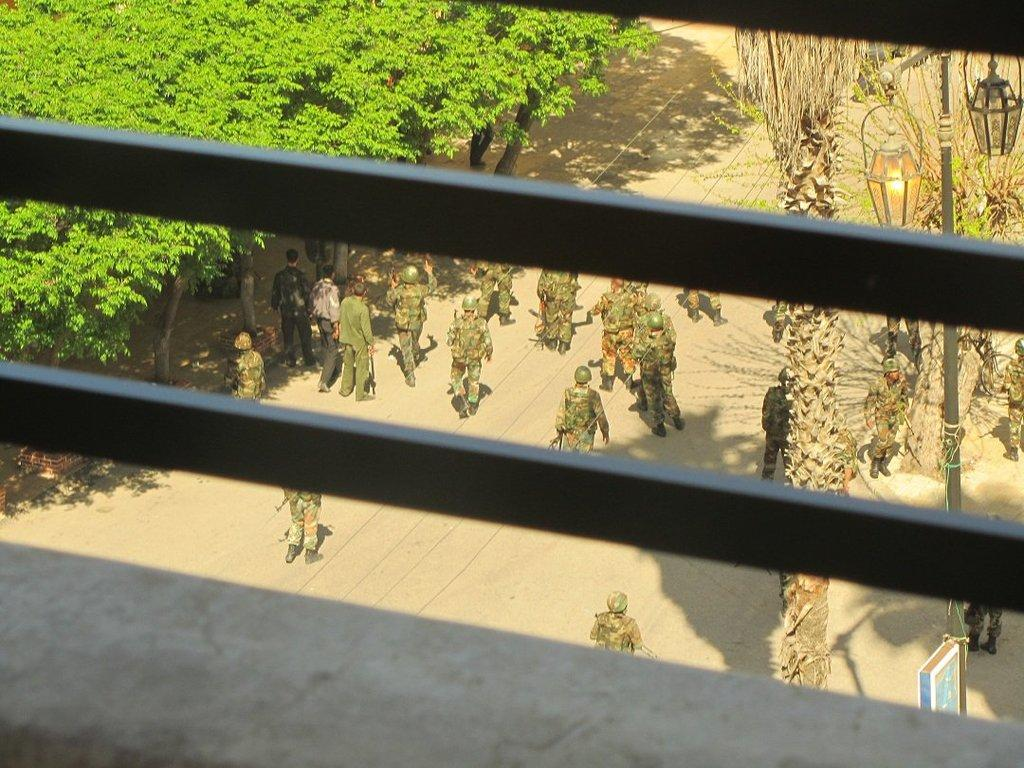What is the main feature in the middle of the picture? There is a black color railing in the middle of the picture. What can be seen in the background of the image? There are soldiers on the road in the background. What type of vegetation is on the left side of the image? There are trees on the left side of the image. Where is the school located in the image? There is no school present in the image. What type of rifle is being used by the soldiers in the image? There are no rifles visible in the image; only soldiers on the road are present. 